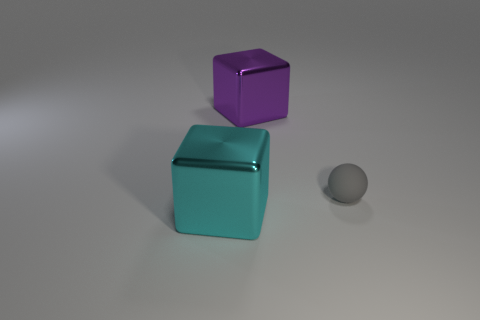Are there any other things that have the same size as the ball?
Your response must be concise. No. Are there any other things that are the same material as the gray ball?
Keep it short and to the point. No. Are there any small brown cylinders made of the same material as the gray sphere?
Your answer should be very brief. No. What is the material of the big cube behind the big metal cube in front of the tiny gray sphere?
Your response must be concise. Metal. There is a thing that is both left of the gray rubber sphere and behind the big cyan shiny thing; what material is it?
Make the answer very short. Metal. Are there an equal number of purple things that are right of the gray matte object and large yellow objects?
Provide a short and direct response. Yes. What number of other objects have the same shape as the tiny thing?
Provide a succinct answer. 0. What is the size of the cube that is right of the big metal block that is in front of the big purple metal cube on the left side of the gray matte ball?
Provide a succinct answer. Large. Are the object that is in front of the tiny sphere and the small gray ball made of the same material?
Your answer should be very brief. No. Are there an equal number of large purple things to the right of the rubber sphere and gray balls in front of the big cyan cube?
Keep it short and to the point. Yes. 